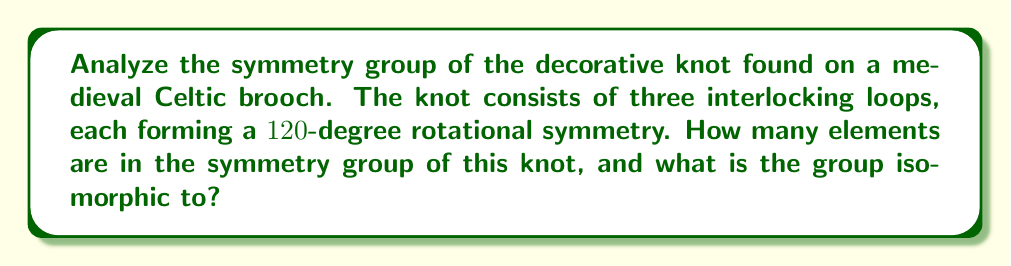Help me with this question. Let's approach this step-by-step:

1) First, we need to identify the symmetries of the knot:
   - It has 3-fold rotational symmetry (120° rotations)
   - It has 3 reflection symmetries (across axes that bisect each loop)

2) Let's count the elements of the symmetry group:
   - Identity transformation (do nothing): 1 element
   - Rotations: 2 elements (120° and 240° rotations)
   - Reflections: 3 elements

3) Total number of elements: 1 + 2 + 3 = 6

4) Now, let's identify the group structure:
   - It has 6 elements
   - It contains rotations and reflections

5) This structure matches the dihedral group $D_3$, which is the symmetry group of an equilateral triangle.

6) To confirm, let's check the group properties:
   - $D_3$ is generated by a rotation $r$ of order 3 and a reflection $s$
   - The elements are: $\{e, r, r^2, s, sr, sr^2\}$
   - This matches our count and types of symmetries

7) Therefore, the symmetry group of this knot is isomorphic to $D_3$.

8) In abstract algebra notation:
   $$ G \cong D_3 \cong S_3 $$
   where $S_3$ is the symmetric group on 3 elements.
Answer: 6 elements; isomorphic to $D_3$ 